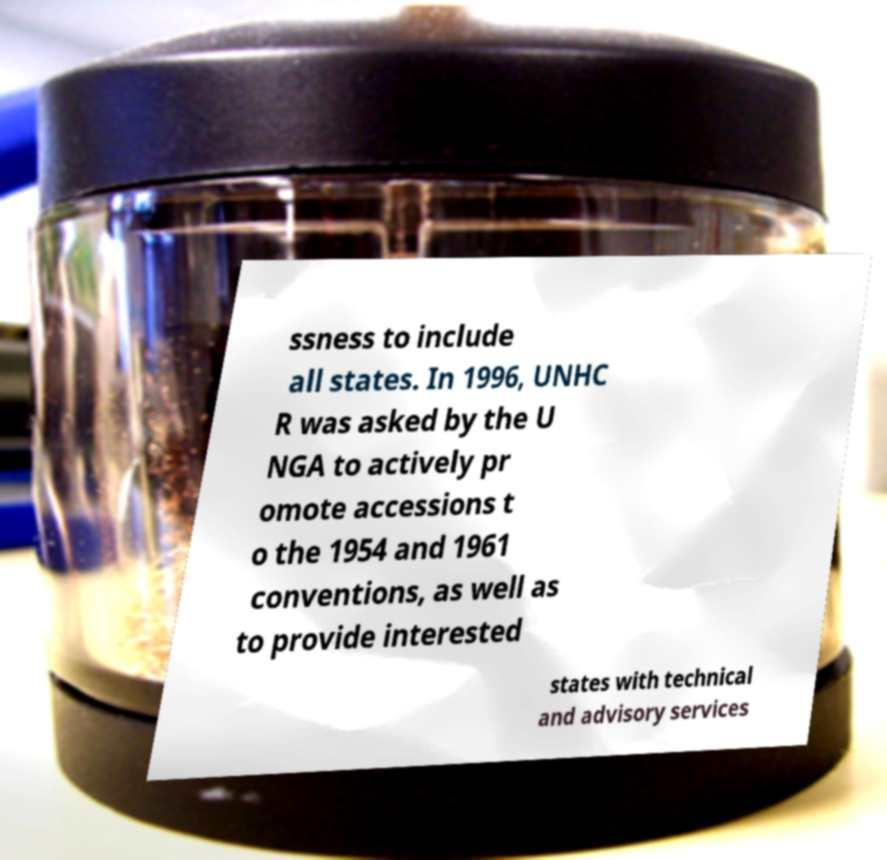Please identify and transcribe the text found in this image. ssness to include all states. In 1996, UNHC R was asked by the U NGA to actively pr omote accessions t o the 1954 and 1961 conventions, as well as to provide interested states with technical and advisory services 